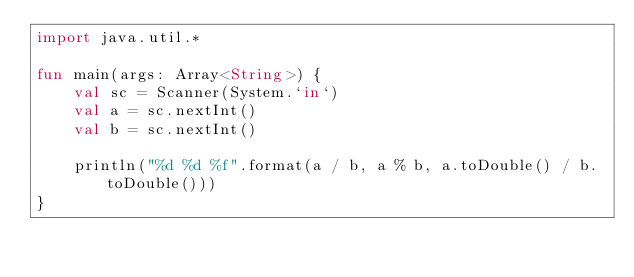<code> <loc_0><loc_0><loc_500><loc_500><_Kotlin_>import java.util.*

fun main(args: Array<String>) {
    val sc = Scanner(System.`in`)
    val a = sc.nextInt()
    val b = sc.nextInt()
    
    println("%d %d %f".format(a / b, a % b, a.toDouble() / b.toDouble()))
}
</code> 